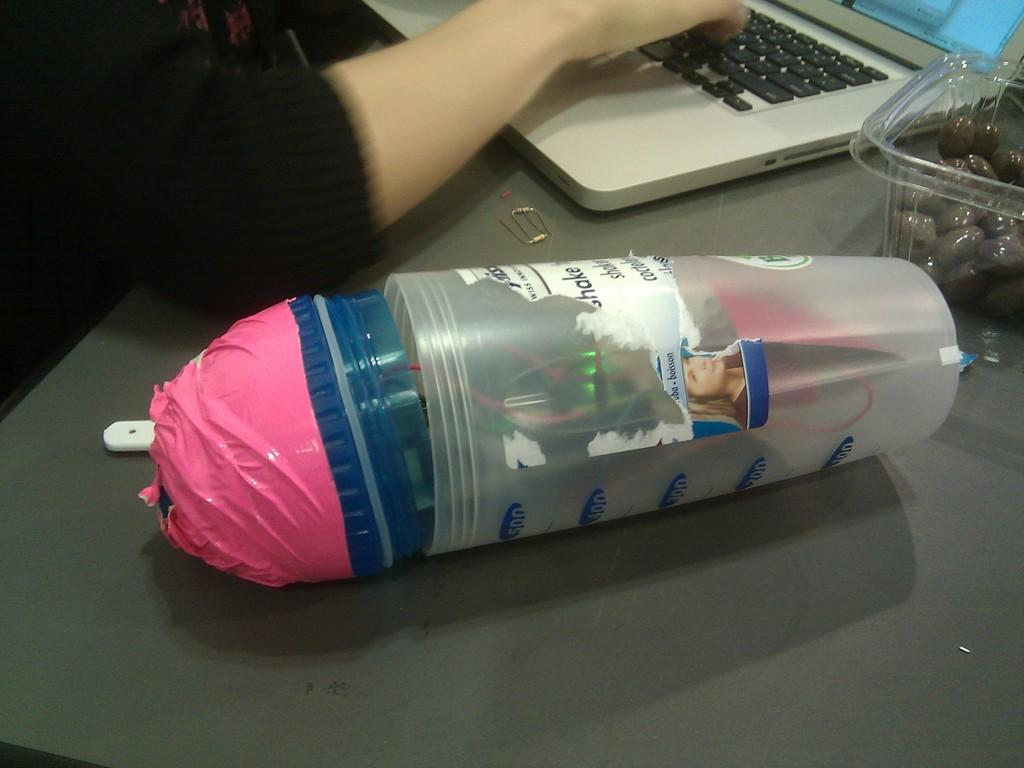<image>
Share a concise interpretation of the image provided. A blender bottle is laying on its side showing a sticker that says shake on it. 